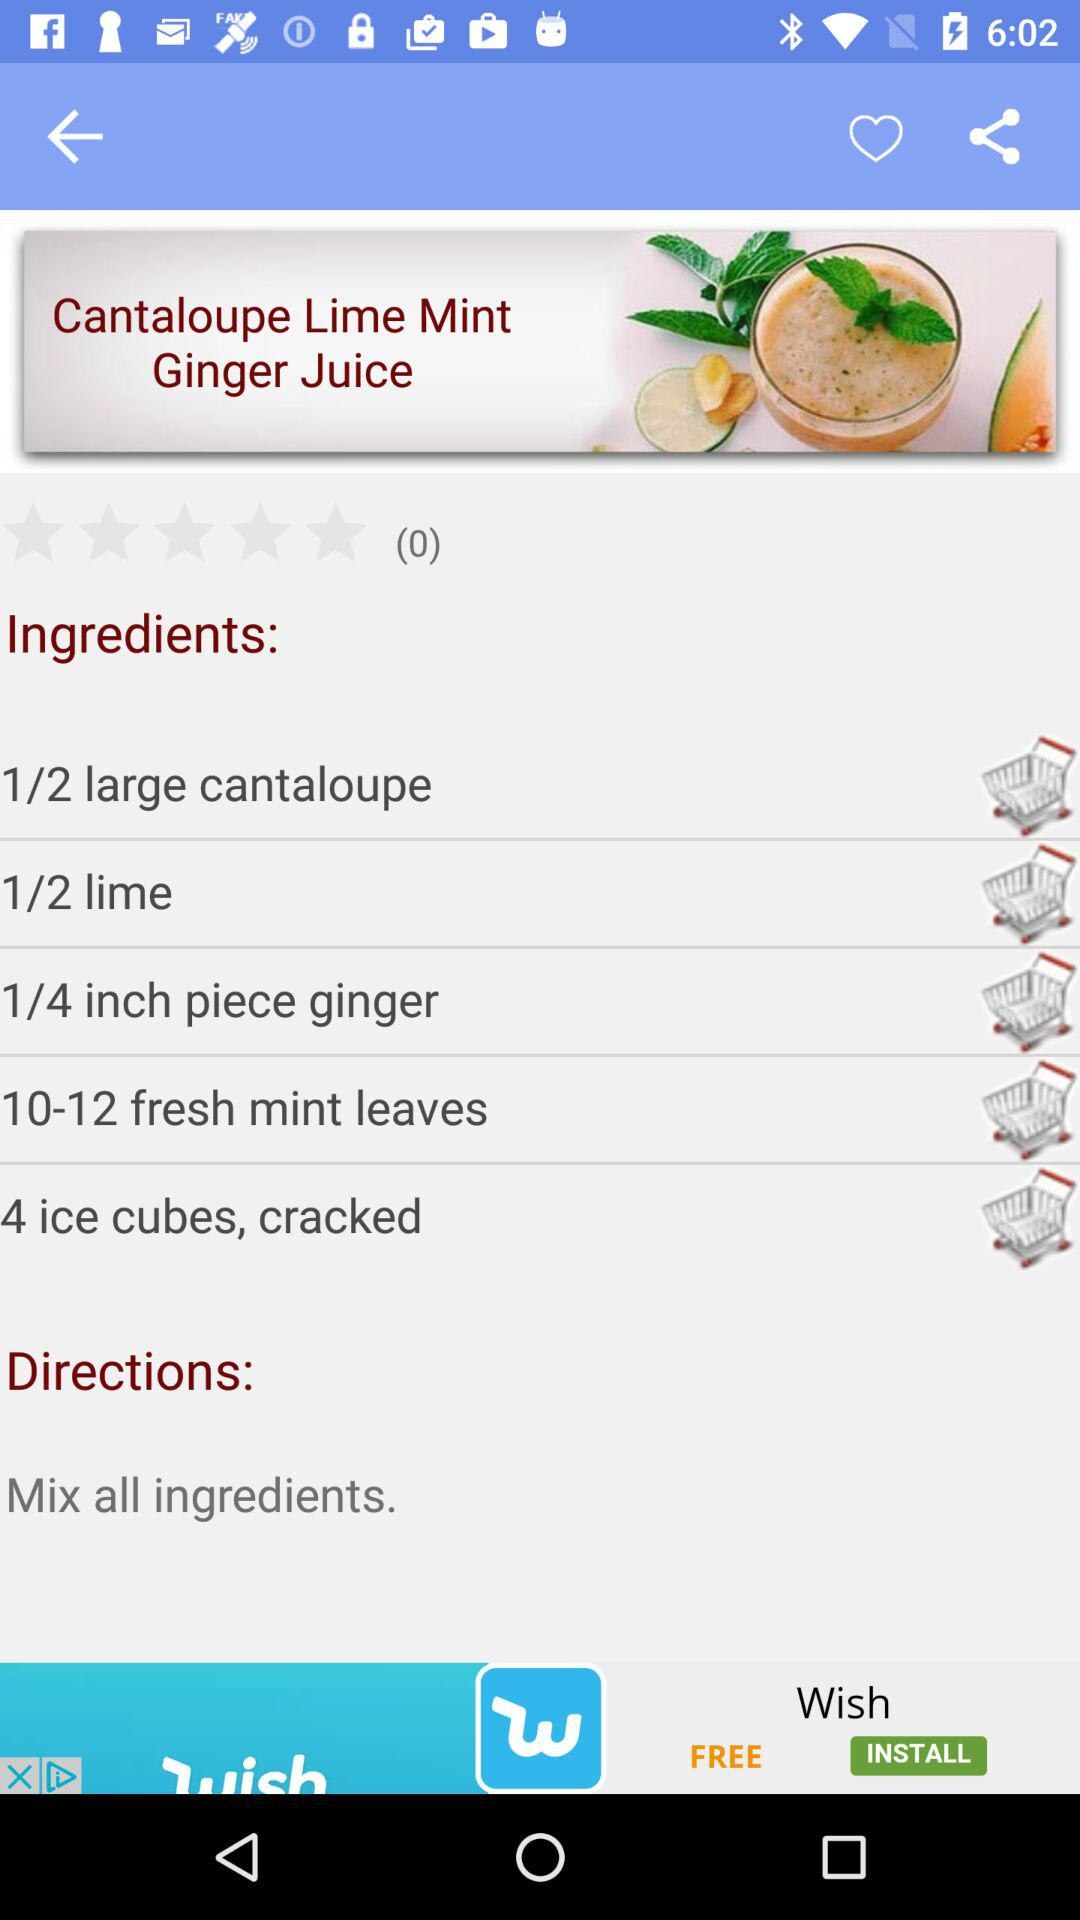What is the mentioned directions for the Cantaloupe Lime Mint Ginger Juice? The directions is "Mix all ingredients". 